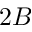Convert formula to latex. <formula><loc_0><loc_0><loc_500><loc_500>2 B</formula> 